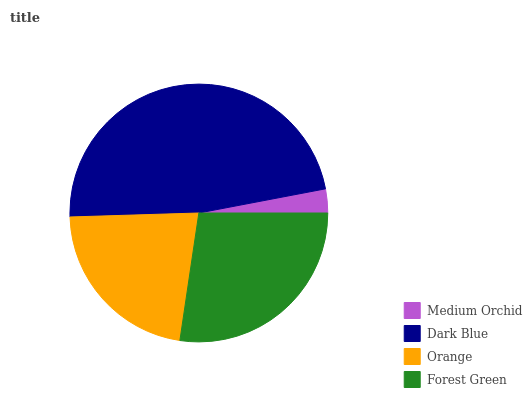Is Medium Orchid the minimum?
Answer yes or no. Yes. Is Dark Blue the maximum?
Answer yes or no. Yes. Is Orange the minimum?
Answer yes or no. No. Is Orange the maximum?
Answer yes or no. No. Is Dark Blue greater than Orange?
Answer yes or no. Yes. Is Orange less than Dark Blue?
Answer yes or no. Yes. Is Orange greater than Dark Blue?
Answer yes or no. No. Is Dark Blue less than Orange?
Answer yes or no. No. Is Forest Green the high median?
Answer yes or no. Yes. Is Orange the low median?
Answer yes or no. Yes. Is Orange the high median?
Answer yes or no. No. Is Dark Blue the low median?
Answer yes or no. No. 